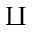Convert formula to latex. <formula><loc_0><loc_0><loc_500><loc_500>\amalg</formula> 